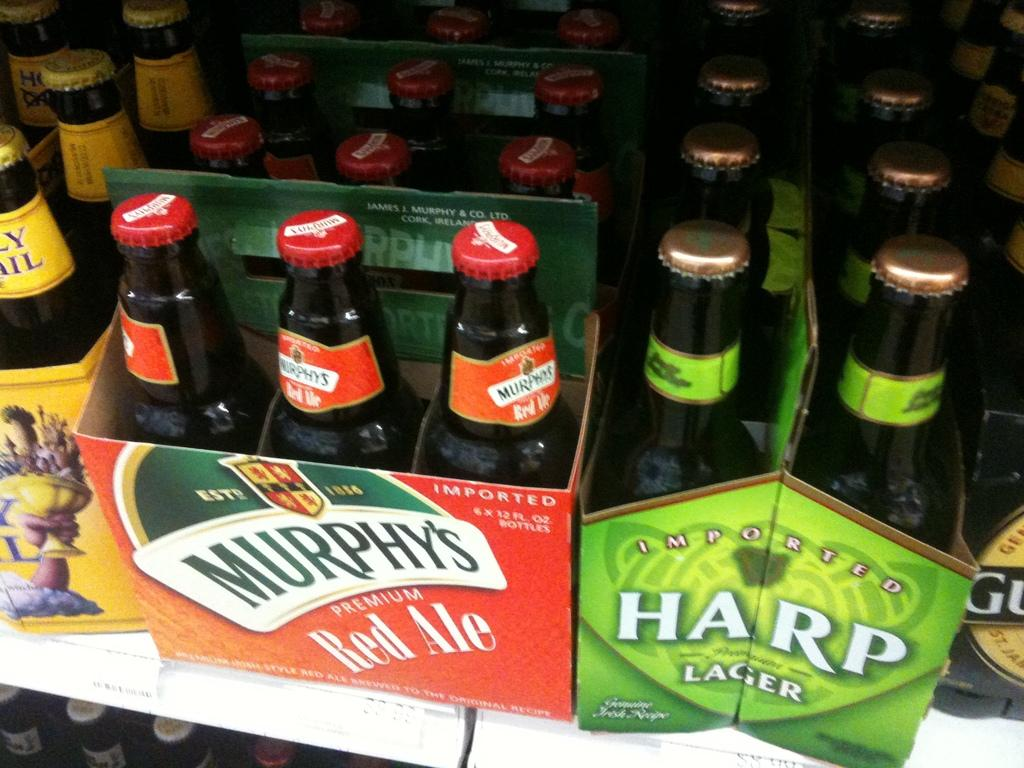<image>
Create a compact narrative representing the image presented. bottles of Murphy's Red Ale next to Harp Lager 